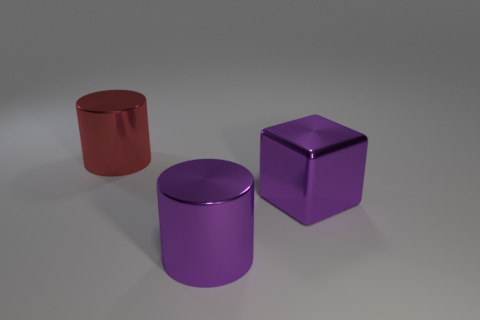The metallic object that is the same color as the large shiny cube is what size?
Make the answer very short. Large. What number of other things are there of the same shape as the large red thing?
Provide a short and direct response. 1. Are there any big blocks that are on the right side of the metallic cylinder to the right of the large red thing?
Give a very brief answer. Yes. What number of metal objects are large yellow things or large cylinders?
Ensure brevity in your answer.  2. There is a big purple object behind the cylinder that is to the right of the large red metal cylinder; is there a large purple shiny cylinder left of it?
Provide a succinct answer. Yes. There is a large purple object that is the same material as the purple cylinder; what is its shape?
Your answer should be very brief. Cube. Is the number of purple blocks that are on the right side of the cube less than the number of large purple metal cylinders that are behind the large purple cylinder?
Provide a succinct answer. No. How many large things are either purple cubes or brown shiny cylinders?
Make the answer very short. 1. Does the large purple shiny thing that is on the right side of the purple cylinder have the same shape as the purple metal object that is on the left side of the purple metallic block?
Your answer should be compact. No. How many red things are either large metal cylinders or large metallic cubes?
Offer a very short reply. 1. 